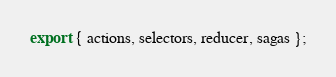<code> <loc_0><loc_0><loc_500><loc_500><_TypeScript_>export { actions, selectors, reducer, sagas };
</code> 